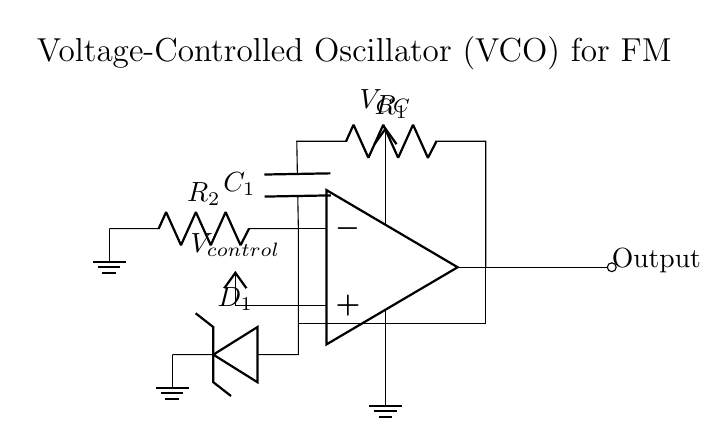What type of diode is used in this circuit? The circuit contains a varactor diode, which is indicated by the symbol labeled as D_1. Varactor diodes are used for their ability to change capacitance based on the voltage applied.
Answer: varactor diode What is the purpose of the resistor labeled R_1? R_1 is part of the feedback network, which influences the gain of the op-amp and ultimately affects the frequency of oscillation. The value of R_1 can have significant effects on the oscillator's performance.
Answer: feedback What component provides control voltage to the VCO? The control voltage is supplied from the voltage source labeled as V_control. This voltage adjusts the frequency output of the oscillator effectively.
Answer: V_control What happens to the output frequency when the control voltage increases? Increasing the control voltage typically increases the capacitance in the varactor diode, which decreases the oscillation frequency in a VCO. This frequency modulation is crucial in communication applications.
Answer: decreases Describe the power supply connections in this circuit. The circuit has a power supply labeled as V_CC connected to the op-amp, ensuring it operates within the required voltage range. Additionally, there is a ground connection for completing the circuit.
Answer: V_CC and ground What is the role of the capacitor labeled C_1 in the feedback network? C_1 is used for tuning the frequency of the oscillator by creating a timing interval along with resistors R_1 and R_2. It directly influences the phase shift and stability of the oscillation frequency.
Answer: tuning frequency What can be inferred about the stability of the VCO based on the component configuration? The stability of the VCO is influenced by the choice and values of components like R_1, R_2, and C_1, which form a feedback loop. Proper design ensures that the oscillator stays within limits of operation without oscillating uncontrollably.
Answer: component values 